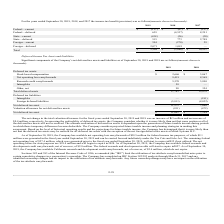According to Mitek Systems's financial document, How does the Company assess the realizability of deferred tax assets? the Company considers whether it is more likely than not that some portion or all of the deferred tax assets will not be realized. The document states: "sessing the realizability of deferred tax assets, the Company considers whether it is more likely than not that some portion or all of the deferred ta..." Also, Which laws limit the utilization of tax attribute carryforwards that arise prior to certain cumulative changes in a corporation’s ownership? Sections 382 and 383 of the Internal Revenue Code of 1986. The document states: "Sections 382 and 383 of the Internal Revenue Code of 1986, as amended (the “IRC”) limit the utilization of tax attribute carryforwards that arise prio..." Also, What are the Company’s net deferred tax assets in 2018 and 2019, respectively? The document shows two values: $7,194 and $11,041 (in thousands). From the document: "Net deferred tax asset $ 11,041 $ 7,194 Net deferred tax asset $ 11,041 $ 7,194..." Also, can you calculate: What is the proportion of research credit carryforwards and intangible assets over total deferred assets in 2019? To answer this question, I need to perform calculations using the financial data. The calculation is: (5,570+58)/17,783 , which equals 0.32. This is based on the information: "Total deferred assets 17,783 15,879 Research credit carryforwards 5,570 3,890 Intangibles 58 —..." The key data points involved are: 17,783, 5,570, 58. Also, can you calculate: What is the percentage change in net deferred tax assets from 2018 to 2019? To answer this question, I need to perform calculations using the financial data. The calculation is: (11,041-7,194)/7,194 , which equals 53.48 (percentage). This is based on the information: "Net deferred tax asset $ 11,041 $ 7,194 Net deferred tax asset $ 11,041 $ 7,194..." The key data points involved are: 11,041, 7,194. Also, can you calculate: What is the average of total deferred assets from 2018 to 2019? To answer this question, I need to perform calculations using the financial data. The calculation is: (17,783+15,879)/2 , which equals 16831 (in thousands). This is based on the information: "Total deferred assets 17,783 15,879 Total deferred assets 17,783 15,879..." The key data points involved are: 15,879, 17,783. 